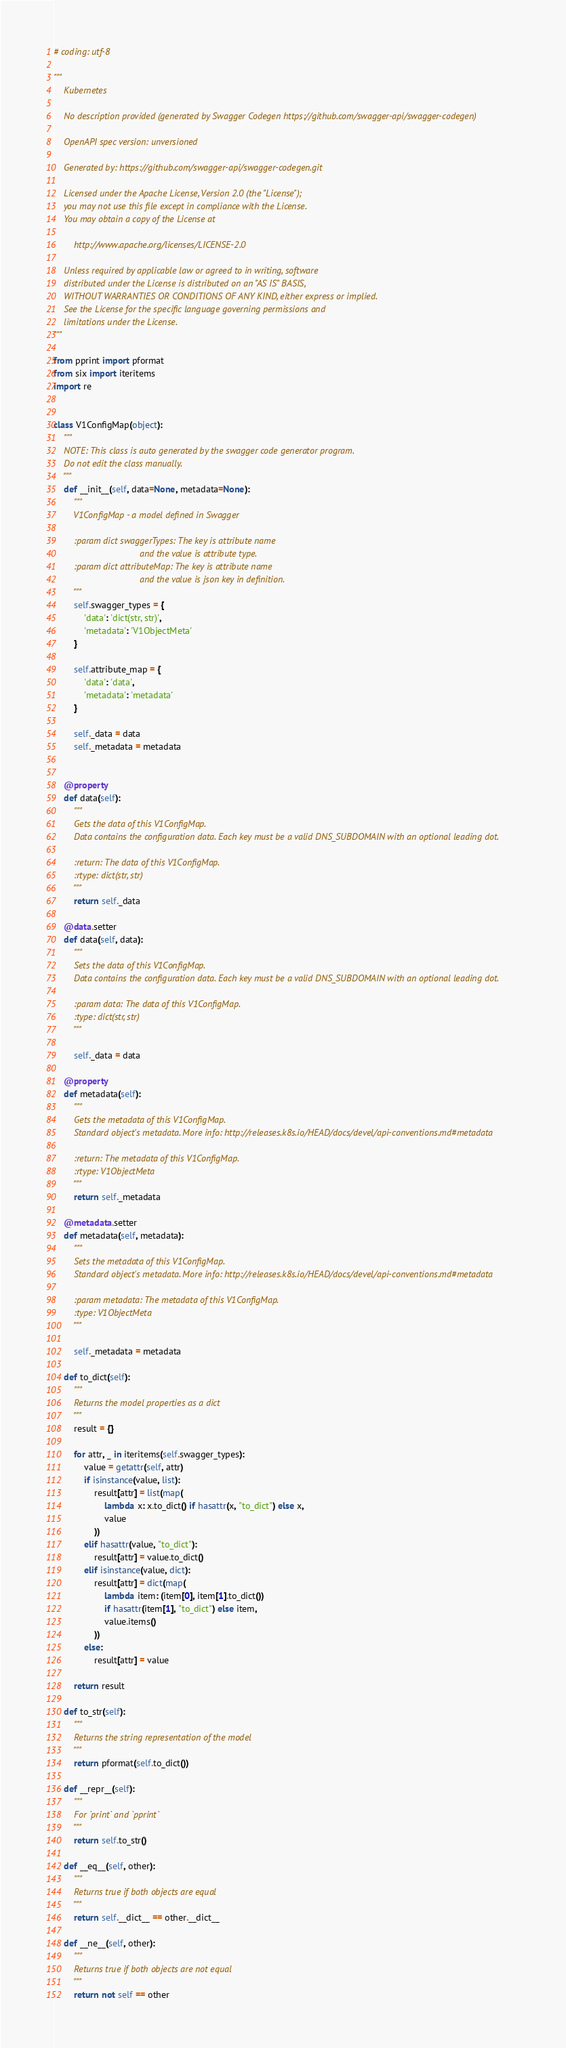<code> <loc_0><loc_0><loc_500><loc_500><_Python_># coding: utf-8

"""
    Kubernetes

    No description provided (generated by Swagger Codegen https://github.com/swagger-api/swagger-codegen)

    OpenAPI spec version: unversioned
    
    Generated by: https://github.com/swagger-api/swagger-codegen.git

    Licensed under the Apache License, Version 2.0 (the "License");
    you may not use this file except in compliance with the License.
    You may obtain a copy of the License at

        http://www.apache.org/licenses/LICENSE-2.0

    Unless required by applicable law or agreed to in writing, software
    distributed under the License is distributed on an "AS IS" BASIS,
    WITHOUT WARRANTIES OR CONDITIONS OF ANY KIND, either express or implied.
    See the License for the specific language governing permissions and
    limitations under the License.
"""

from pprint import pformat
from six import iteritems
import re


class V1ConfigMap(object):
    """
    NOTE: This class is auto generated by the swagger code generator program.
    Do not edit the class manually.
    """
    def __init__(self, data=None, metadata=None):
        """
        V1ConfigMap - a model defined in Swagger

        :param dict swaggerTypes: The key is attribute name
                                  and the value is attribute type.
        :param dict attributeMap: The key is attribute name
                                  and the value is json key in definition.
        """
        self.swagger_types = {
            'data': 'dict(str, str)',
            'metadata': 'V1ObjectMeta'
        }

        self.attribute_map = {
            'data': 'data',
            'metadata': 'metadata'
        }

        self._data = data
        self._metadata = metadata


    @property
    def data(self):
        """
        Gets the data of this V1ConfigMap.
        Data contains the configuration data. Each key must be a valid DNS_SUBDOMAIN with an optional leading dot.

        :return: The data of this V1ConfigMap.
        :rtype: dict(str, str)
        """
        return self._data

    @data.setter
    def data(self, data):
        """
        Sets the data of this V1ConfigMap.
        Data contains the configuration data. Each key must be a valid DNS_SUBDOMAIN with an optional leading dot.

        :param data: The data of this V1ConfigMap.
        :type: dict(str, str)
        """

        self._data = data

    @property
    def metadata(self):
        """
        Gets the metadata of this V1ConfigMap.
        Standard object's metadata. More info: http://releases.k8s.io/HEAD/docs/devel/api-conventions.md#metadata

        :return: The metadata of this V1ConfigMap.
        :rtype: V1ObjectMeta
        """
        return self._metadata

    @metadata.setter
    def metadata(self, metadata):
        """
        Sets the metadata of this V1ConfigMap.
        Standard object's metadata. More info: http://releases.k8s.io/HEAD/docs/devel/api-conventions.md#metadata

        :param metadata: The metadata of this V1ConfigMap.
        :type: V1ObjectMeta
        """

        self._metadata = metadata

    def to_dict(self):
        """
        Returns the model properties as a dict
        """
        result = {}

        for attr, _ in iteritems(self.swagger_types):
            value = getattr(self, attr)
            if isinstance(value, list):
                result[attr] = list(map(
                    lambda x: x.to_dict() if hasattr(x, "to_dict") else x,
                    value
                ))
            elif hasattr(value, "to_dict"):
                result[attr] = value.to_dict()
            elif isinstance(value, dict):
                result[attr] = dict(map(
                    lambda item: (item[0], item[1].to_dict())
                    if hasattr(item[1], "to_dict") else item,
                    value.items()
                ))
            else:
                result[attr] = value

        return result

    def to_str(self):
        """
        Returns the string representation of the model
        """
        return pformat(self.to_dict())

    def __repr__(self):
        """
        For `print` and `pprint`
        """
        return self.to_str()

    def __eq__(self, other):
        """
        Returns true if both objects are equal
        """
        return self.__dict__ == other.__dict__

    def __ne__(self, other):
        """
        Returns true if both objects are not equal
        """
        return not self == other
</code> 